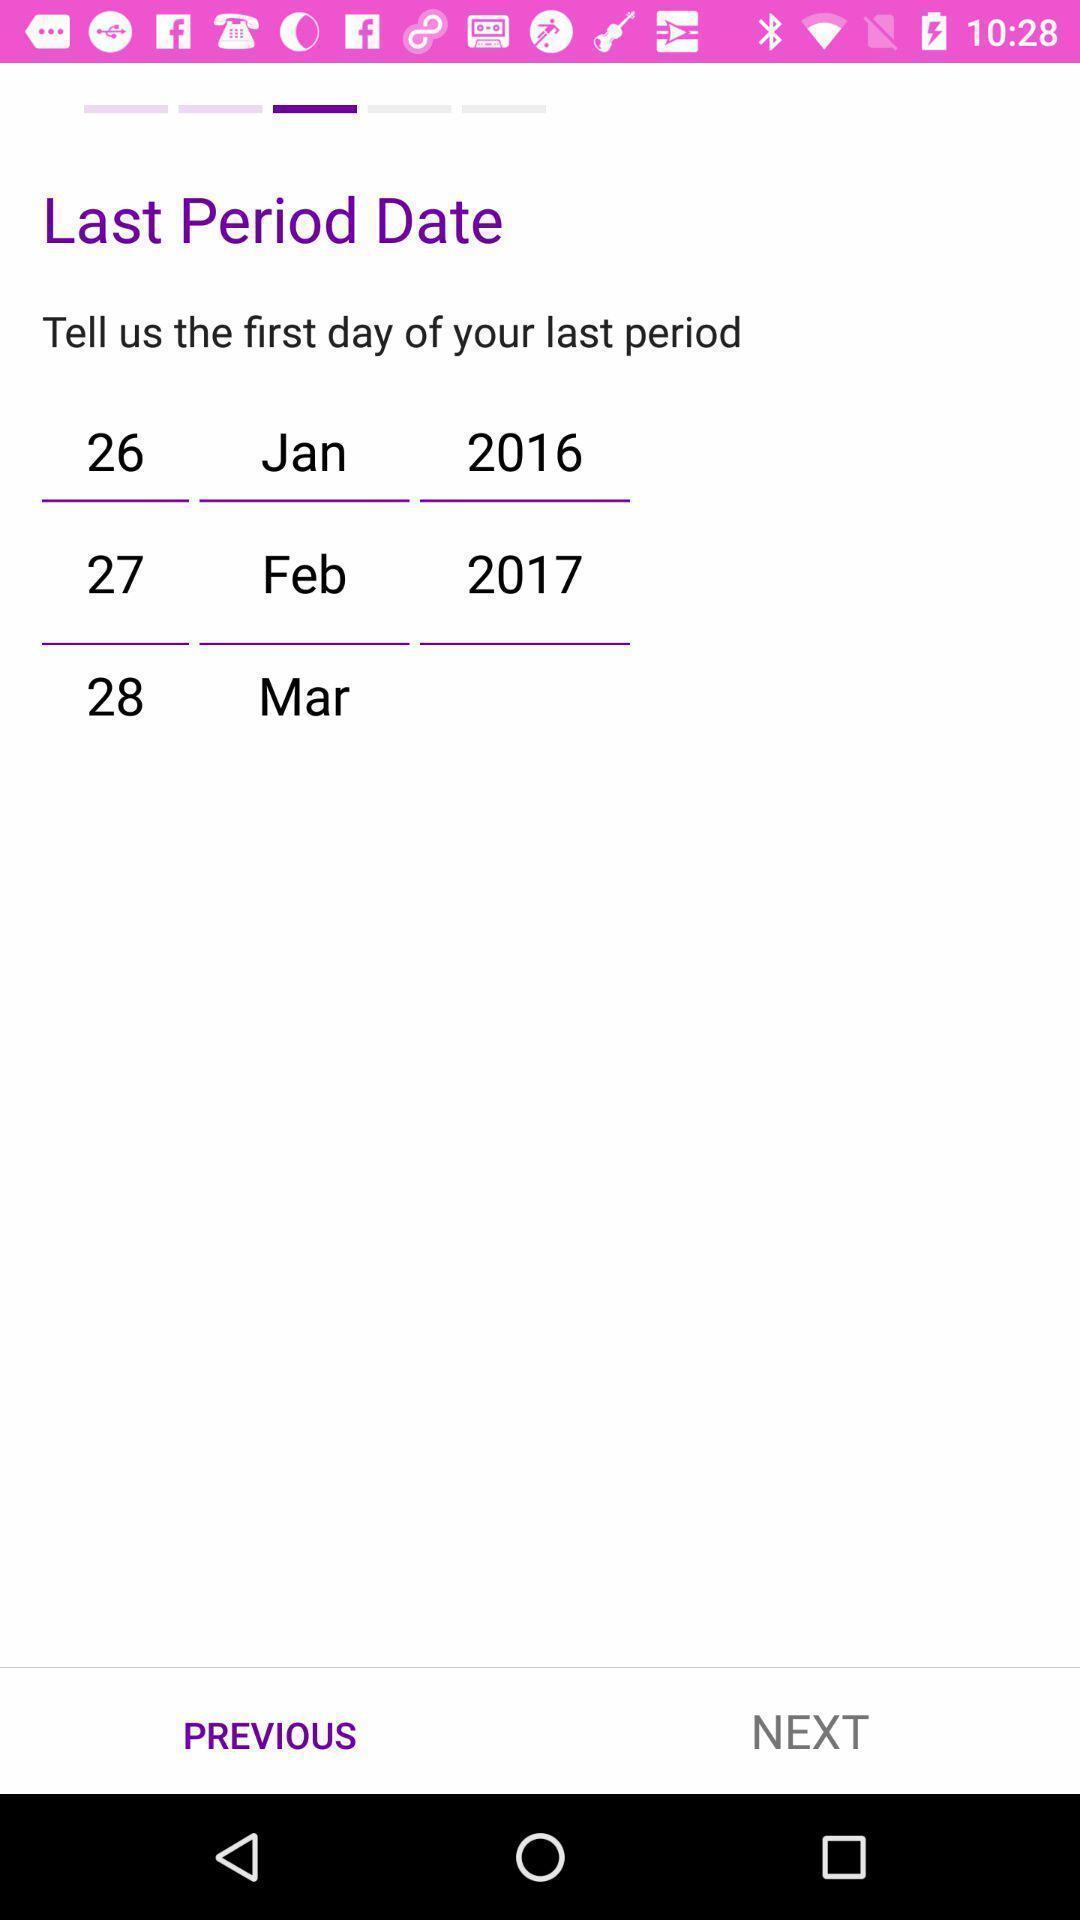Describe the key features of this screenshot. Screen shows multiple options in a health application. 